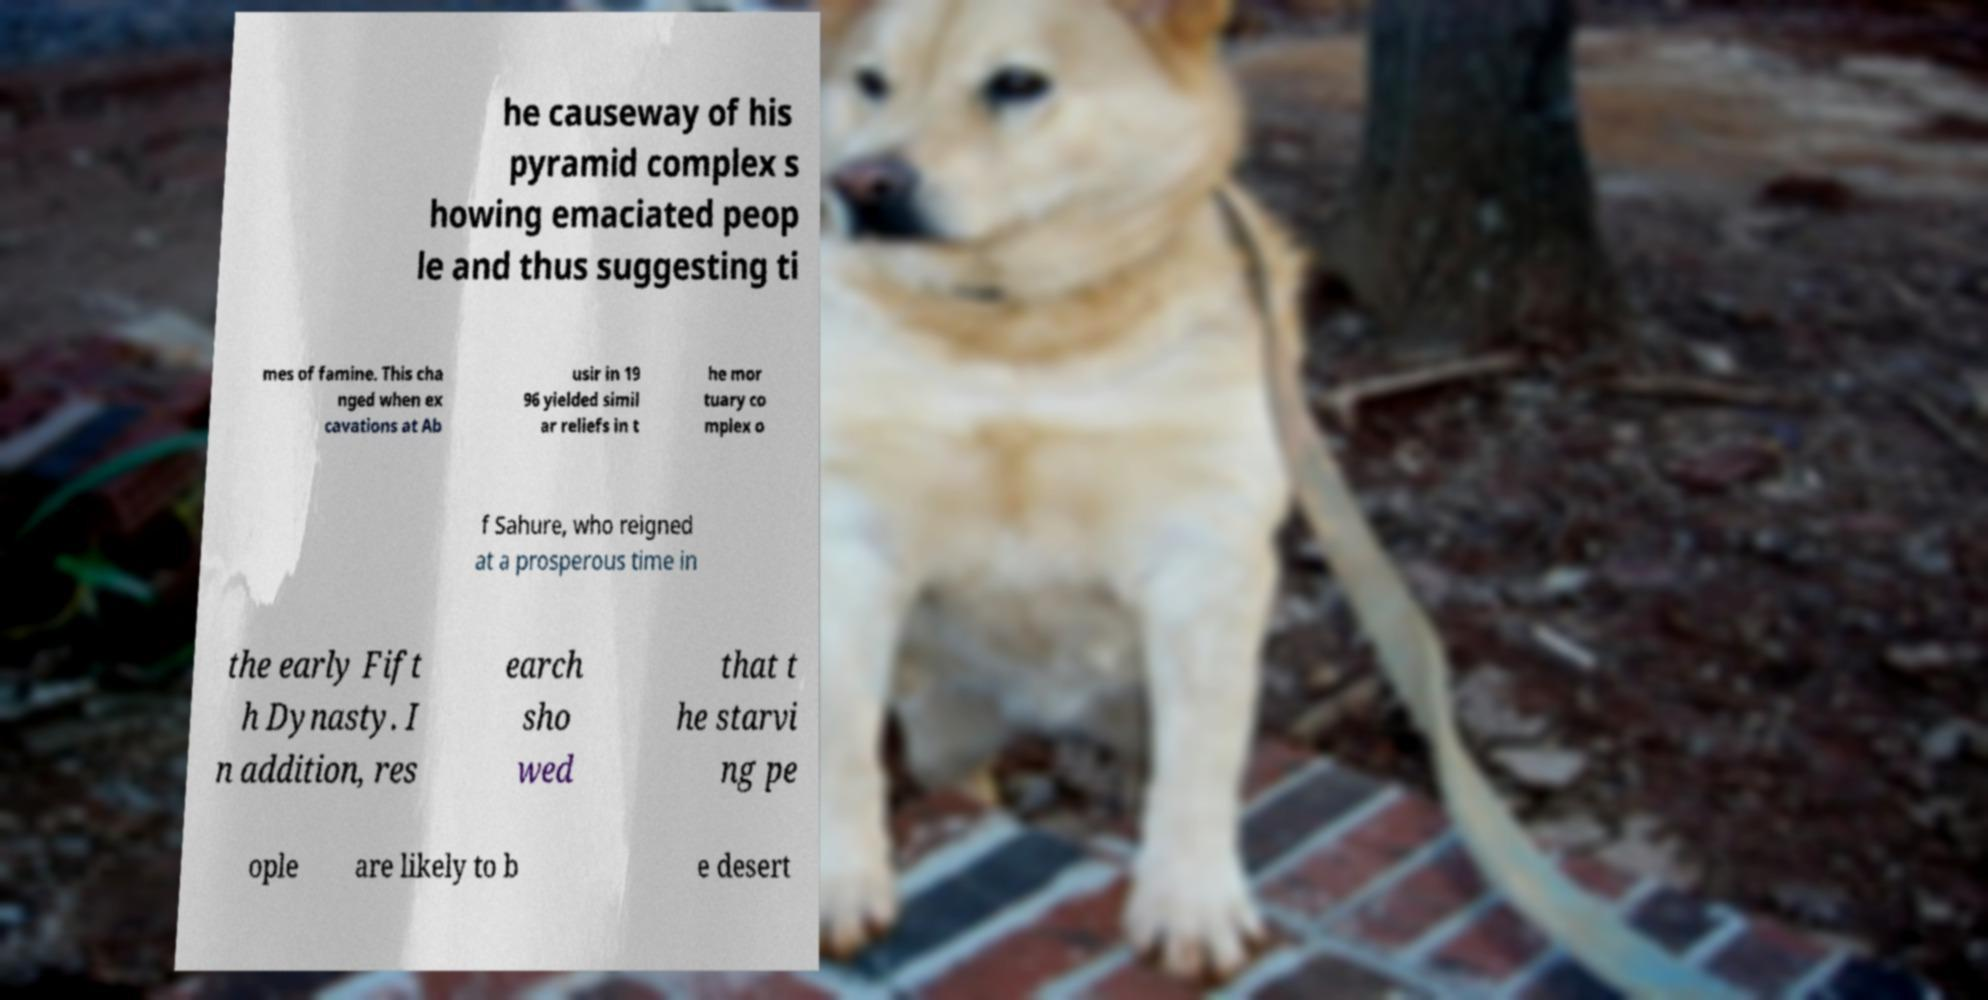Could you assist in decoding the text presented in this image and type it out clearly? he causeway of his pyramid complex s howing emaciated peop le and thus suggesting ti mes of famine. This cha nged when ex cavations at Ab usir in 19 96 yielded simil ar reliefs in t he mor tuary co mplex o f Sahure, who reigned at a prosperous time in the early Fift h Dynasty. I n addition, res earch sho wed that t he starvi ng pe ople are likely to b e desert 